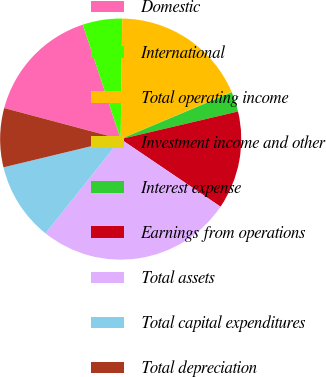<chart> <loc_0><loc_0><loc_500><loc_500><pie_chart><fcel>Domestic<fcel>International<fcel>Total operating income<fcel>Investment income and other<fcel>Interest expense<fcel>Earnings from operations<fcel>Total assets<fcel>Total capital expenditures<fcel>Total depreciation<nl><fcel>15.77%<fcel>5.29%<fcel>18.38%<fcel>0.06%<fcel>2.68%<fcel>13.15%<fcel>26.24%<fcel>10.53%<fcel>7.91%<nl></chart> 